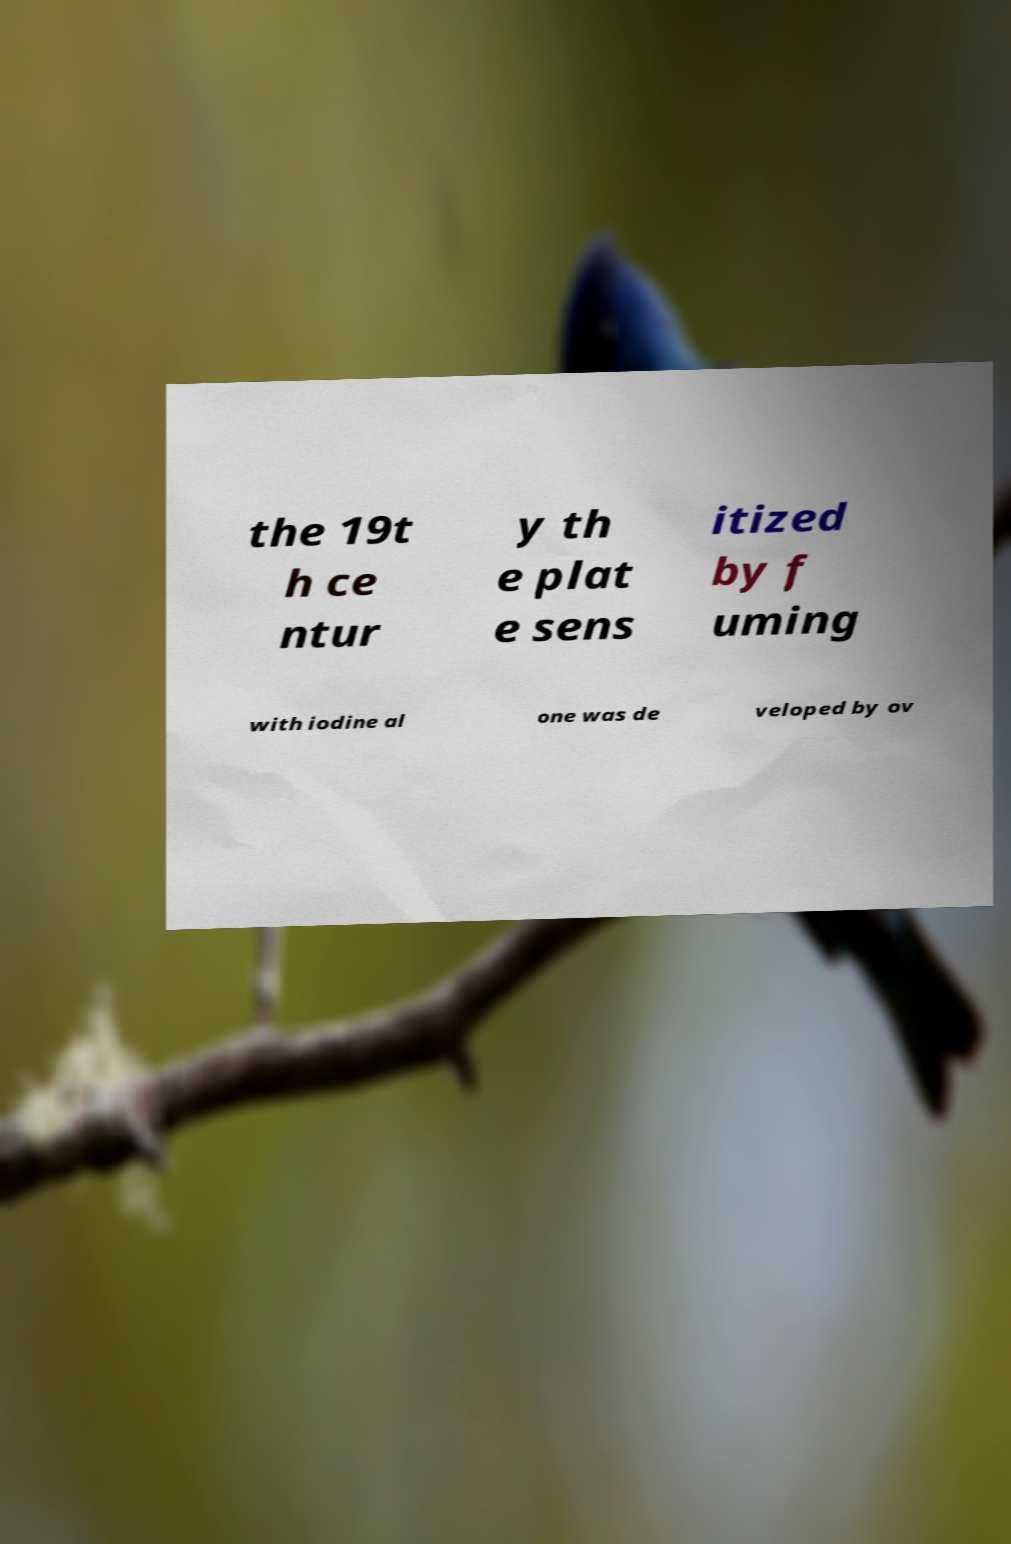Please read and relay the text visible in this image. What does it say? the 19t h ce ntur y th e plat e sens itized by f uming with iodine al one was de veloped by ov 